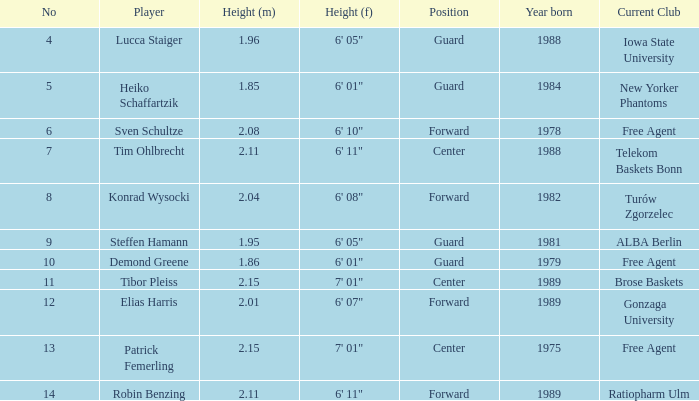Name the height for steffen hamann 6' 05". 